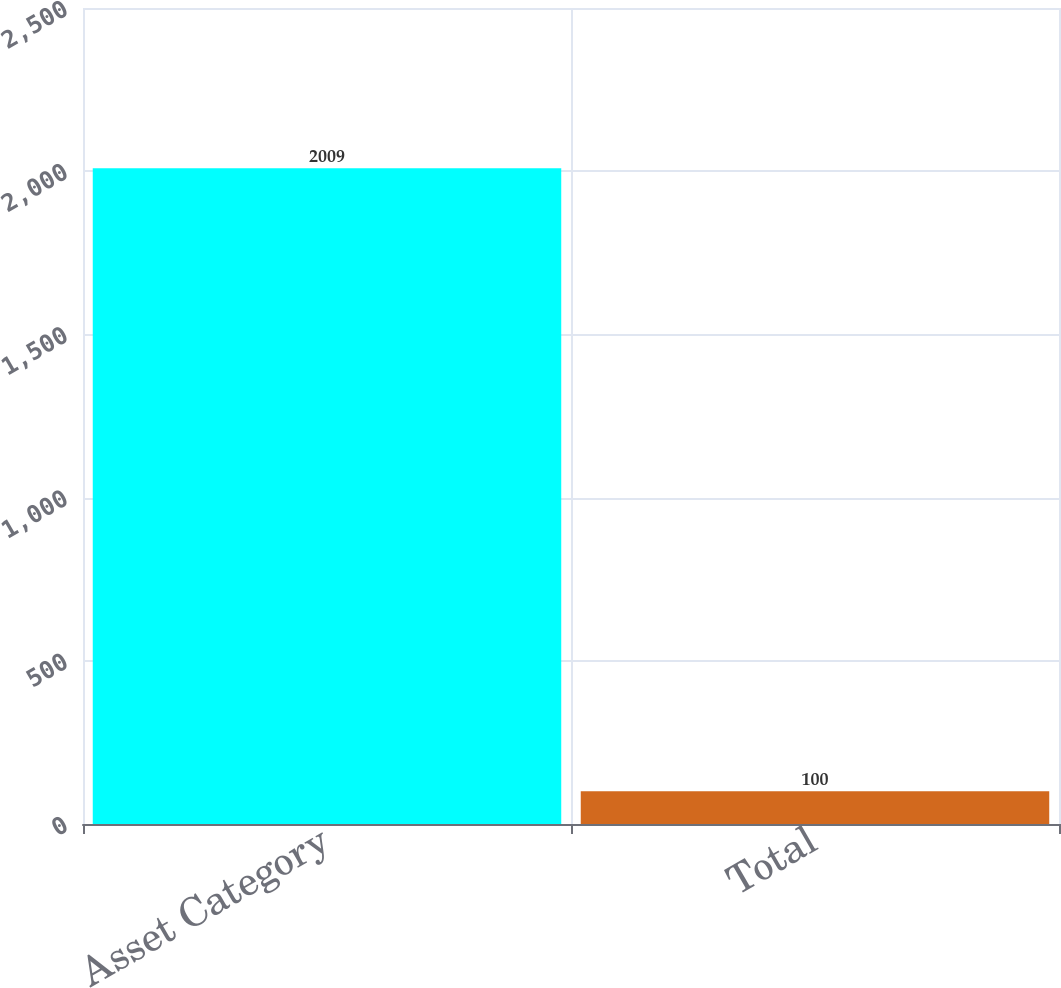Convert chart to OTSL. <chart><loc_0><loc_0><loc_500><loc_500><bar_chart><fcel>Asset Category<fcel>Total<nl><fcel>2009<fcel>100<nl></chart> 